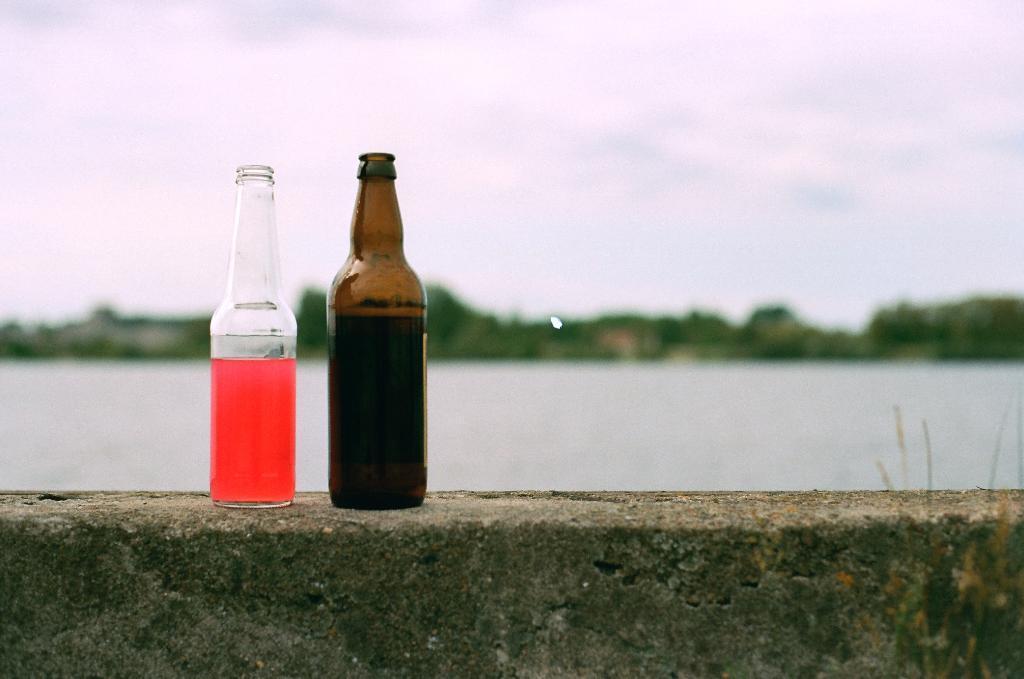Can you describe this image briefly? In this picture there are two Wine bottles kept on a rockin in the background is a lake and the sky is clear 